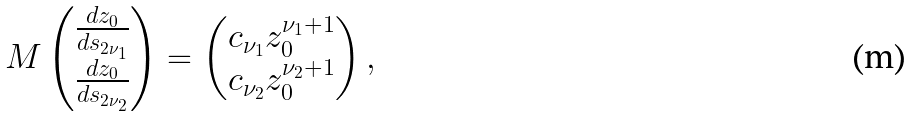<formula> <loc_0><loc_0><loc_500><loc_500>M \begin{pmatrix} \frac { d z _ { 0 } } { d s _ { 2 \nu _ { 1 } } } \\ \frac { d z _ { 0 } } { d s _ { 2 \nu _ { 2 } } } \end{pmatrix} = \begin{pmatrix} c _ { \nu _ { 1 } } z _ { 0 } ^ { \nu _ { 1 } + 1 } \\ c _ { \nu _ { 2 } } z _ { 0 } ^ { \nu _ { 2 } + 1 } \end{pmatrix} ,</formula> 